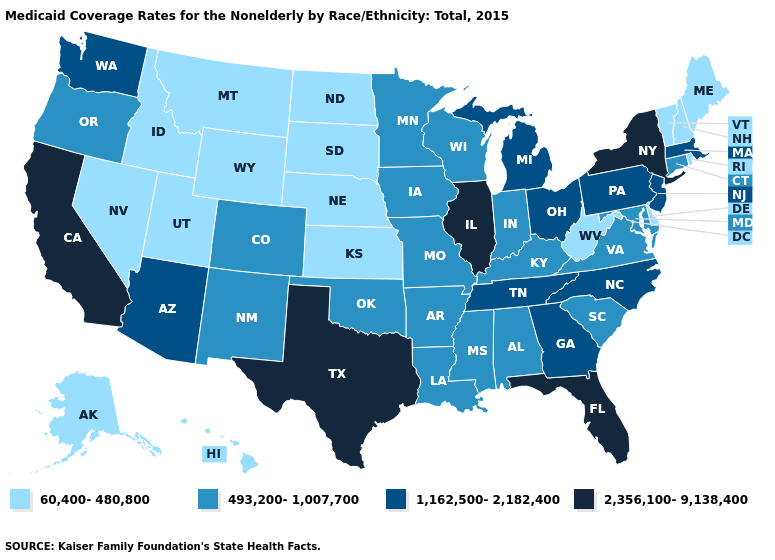Does Vermont have the lowest value in the USA?
Concise answer only. Yes. What is the highest value in states that border North Dakota?
Keep it brief. 493,200-1,007,700. How many symbols are there in the legend?
Answer briefly. 4. Among the states that border California , does Nevada have the lowest value?
Give a very brief answer. Yes. What is the value of Texas?
Give a very brief answer. 2,356,100-9,138,400. Name the states that have a value in the range 2,356,100-9,138,400?
Short answer required. California, Florida, Illinois, New York, Texas. Does Wisconsin have the lowest value in the MidWest?
Concise answer only. No. Name the states that have a value in the range 60,400-480,800?
Concise answer only. Alaska, Delaware, Hawaii, Idaho, Kansas, Maine, Montana, Nebraska, Nevada, New Hampshire, North Dakota, Rhode Island, South Dakota, Utah, Vermont, West Virginia, Wyoming. What is the value of North Dakota?
Give a very brief answer. 60,400-480,800. Does Montana have the highest value in the USA?
Concise answer only. No. Among the states that border Illinois , which have the lowest value?
Short answer required. Indiana, Iowa, Kentucky, Missouri, Wisconsin. What is the value of Colorado?
Concise answer only. 493,200-1,007,700. Name the states that have a value in the range 60,400-480,800?
Short answer required. Alaska, Delaware, Hawaii, Idaho, Kansas, Maine, Montana, Nebraska, Nevada, New Hampshire, North Dakota, Rhode Island, South Dakota, Utah, Vermont, West Virginia, Wyoming. What is the value of Vermont?
Answer briefly. 60,400-480,800. Which states have the lowest value in the USA?
Short answer required. Alaska, Delaware, Hawaii, Idaho, Kansas, Maine, Montana, Nebraska, Nevada, New Hampshire, North Dakota, Rhode Island, South Dakota, Utah, Vermont, West Virginia, Wyoming. 